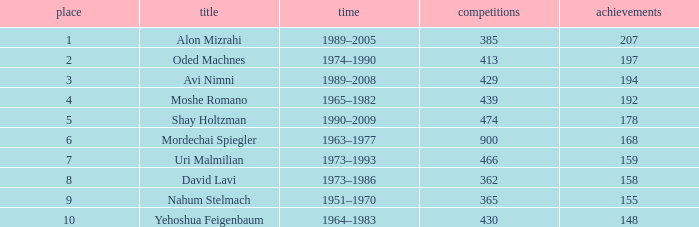What is the Rank of the player with 362 Matches? 8.0. 